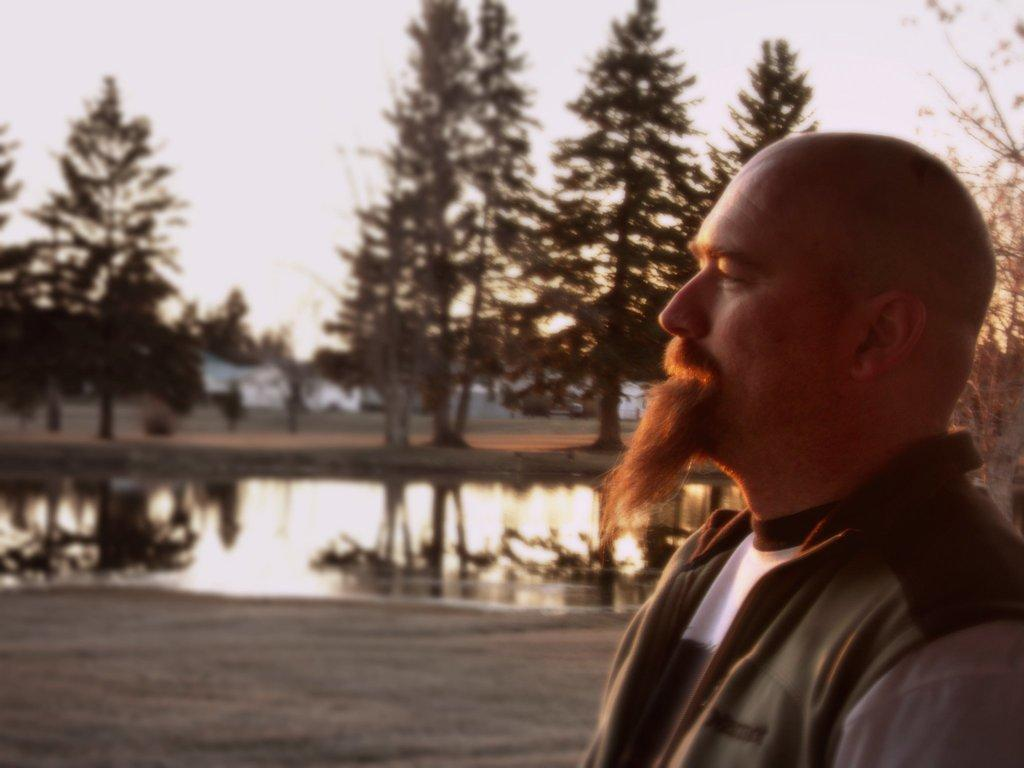Who is present on the right side of the image? There is a man on the right side of the image. What can be seen in the background of the image? There are trees, water, houses, and the sky visible in the background of the image. What language is the man speaking in the image? There is no indication of the man speaking in the image, so it cannot be determined which language he might be using. 